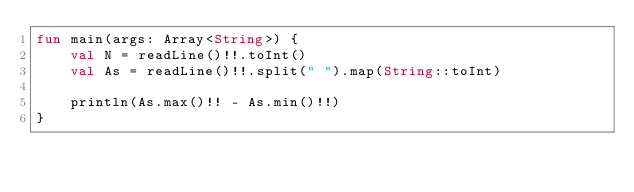Convert code to text. <code><loc_0><loc_0><loc_500><loc_500><_Kotlin_>fun main(args: Array<String>) {
    val N = readLine()!!.toInt()
    val As = readLine()!!.split(" ").map(String::toInt)
    
    println(As.max()!! - As.min()!!)
}
</code> 